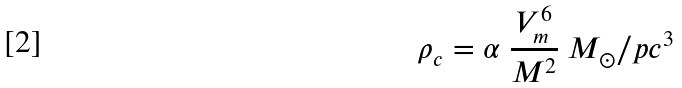Convert formula to latex. <formula><loc_0><loc_0><loc_500><loc_500>\rho _ { c } = \alpha \ \frac { V _ { m } ^ { 6 } } { M ^ { 2 } } \ M _ { \odot } / p c ^ { 3 }</formula> 